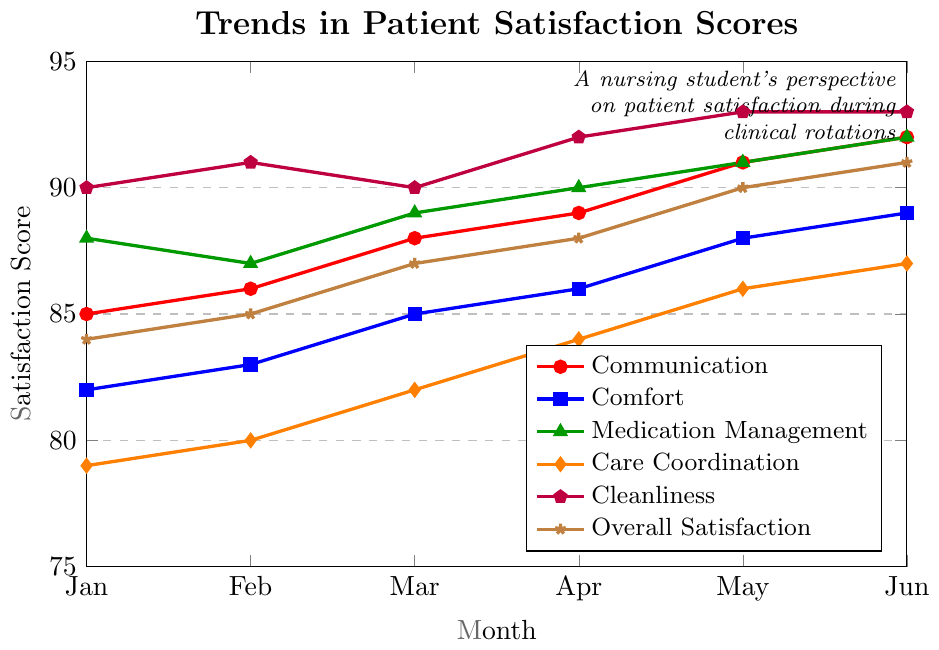Which aspect of care had the highest satisfaction score in January? In January, you can observe that Cleanliness has the highest score out of the different aspects measured, which is 90.
Answer: Cleanliness How did the overall satisfaction score change from January to June? The Overall Satisfaction score in January was 84, and it increased progressively to 91 by June. The change can be calculated as 91 - 84 = 7.
Answer: Increased by 7 Which aspect showed the greatest improvement from January to June? By comparing the differences for each aspect from January to June, Comfort increased by 7 (89 - 82), Communication by 7 (92 - 85), Medication Management by 4 (92 - 88), Care Coordination by 8 (87 - 79), Cleanliness by 3 (93 - 90), and Overall Satisfaction by 7 (91 - 84). Care Coordination showed the greatest improvement.
Answer: Care Coordination Which aspects of care reached or exceeded a satisfaction score of 90 in May? In May, Communication (91), Medication Management (91), Cleanliness (93), and Overall Satisfaction (90) all reached or exceeded a satisfaction score of 90.
Answer: Communication, Medication Management, Cleanliness, Overall Satisfaction What was the trend for Communication satisfaction scores over the 6-month period? Observing the plotted points for Communication over the 6 months: January (85), February (86), March (88), April (89), May (91), June (92), we see a consistent upward trend.
Answer: Upward trend Which month had the smallest difference between Comfort and Care Coordination scores, and what is that difference? We need to calculate the differences: Jan: 82-79=3, Feb: 83-80=3, Mar: 85-82=3, Apr: 86-84=2, May: 88-86=2, Jun: 89-87=2. April, May, and June all have the smallest difference of 2.
Answer: April, May, and June; 2 What is the average satisfaction score for Cleanliness over the 6 months? Add up the scores: 90 (Jan) + 91 (Feb) + 90 (Mar) + 92 (Apr) + 93 (May) + 93 (Jun) = 549. Now, divide by 6: 549 / 6 = 91.5.
Answer: 91.5 Which aspect had the least variation in satisfaction scores over the period? By comparing the range (max-min) of each aspect: Communication (92-85=7), Comfort (89-82=7), Medication Management (92-88=4), Care Coordination (87-79=8), Cleanliness (93-90=3), Overall Satisfaction (91-84=7), Cleanliness had the least variation.
Answer: Cleanliness In which month did Medication Management and Care Coordination have the same satisfaction score? By checking each month's scores, we find that no month shows the same satisfaction score for Medication Management and Care Coordination.
Answer: None What is the median satisfaction score for Overall Satisfaction? The monthly scores for Overall Satisfaction are 84, 85, 87, 88, 90, 91. To find the median from six data points, average the 3rd and 4th scores: (87 + 88) / 2 = 87.5.
Answer: 87.5 